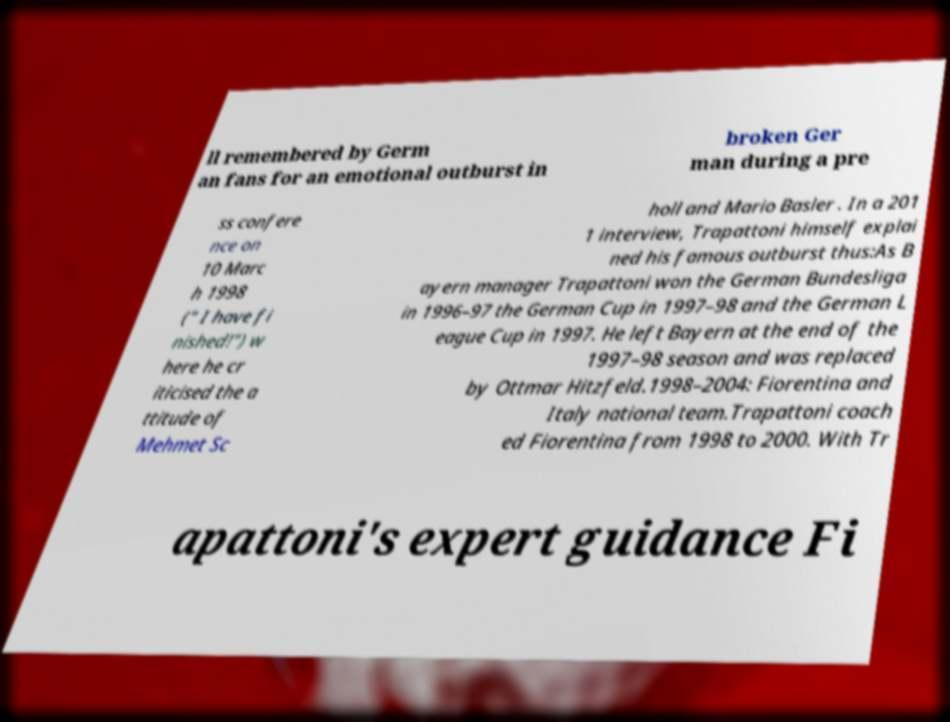What messages or text are displayed in this image? I need them in a readable, typed format. ll remembered by Germ an fans for an emotional outburst in broken Ger man during a pre ss confere nce on 10 Marc h 1998 (" I have fi nished!") w here he cr iticised the a ttitude of Mehmet Sc holl and Mario Basler . In a 201 1 interview, Trapattoni himself explai ned his famous outburst thus:As B ayern manager Trapattoni won the German Bundesliga in 1996–97 the German Cup in 1997–98 and the German L eague Cup in 1997. He left Bayern at the end of the 1997–98 season and was replaced by Ottmar Hitzfeld.1998–2004: Fiorentina and Italy national team.Trapattoni coach ed Fiorentina from 1998 to 2000. With Tr apattoni's expert guidance Fi 